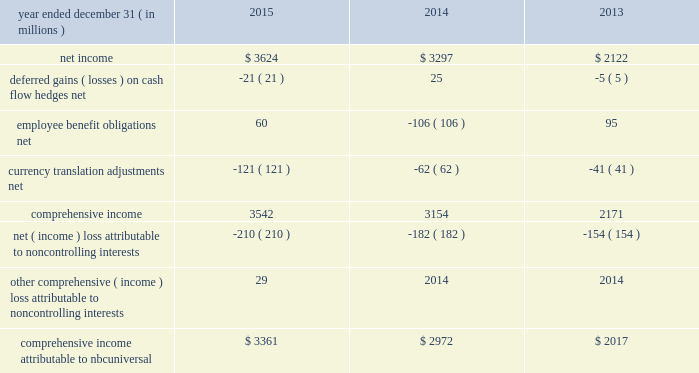Nbcuniversal media , llc consolidated statement of comprehensive income .
See accompanying notes to consolidated financial statements .
147 comcast 2015 annual report on form 10-k .
What is the percentage change in comprehensive income attributable to nbcuniversal from 2014 to 2015? 
Computations: ((3361 - 2972) / 2972)
Answer: 0.13089. 